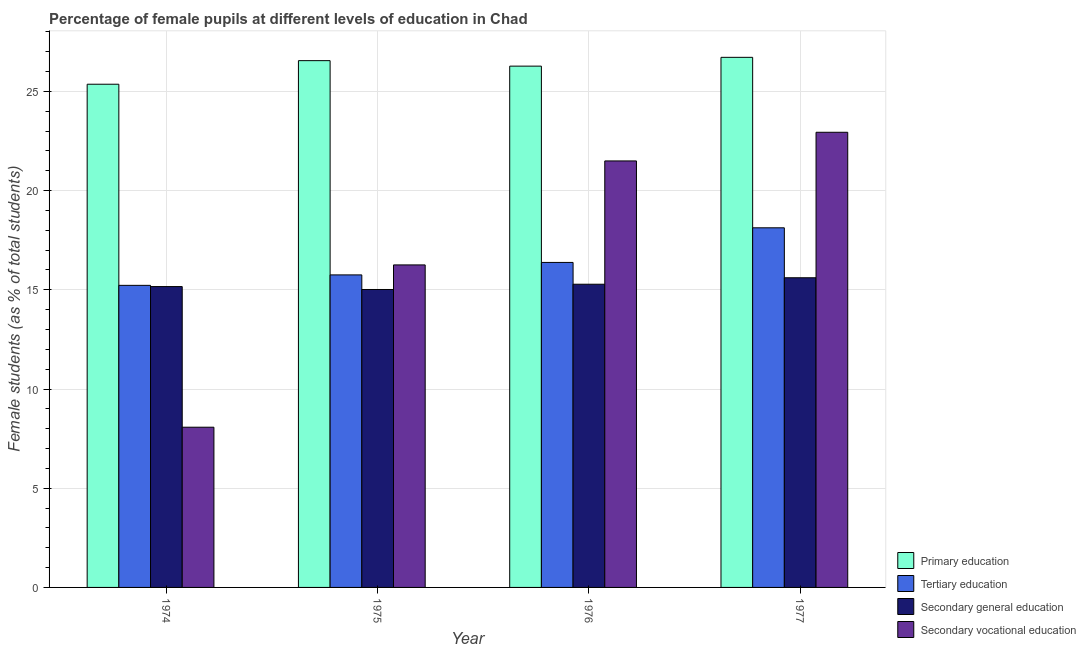How many different coloured bars are there?
Your answer should be very brief. 4. Are the number of bars on each tick of the X-axis equal?
Your response must be concise. Yes. How many bars are there on the 4th tick from the left?
Give a very brief answer. 4. What is the label of the 2nd group of bars from the left?
Provide a short and direct response. 1975. What is the percentage of female students in secondary education in 1975?
Make the answer very short. 15.02. Across all years, what is the maximum percentage of female students in secondary education?
Make the answer very short. 15.61. Across all years, what is the minimum percentage of female students in secondary vocational education?
Ensure brevity in your answer.  8.08. In which year was the percentage of female students in tertiary education maximum?
Keep it short and to the point. 1977. In which year was the percentage of female students in tertiary education minimum?
Offer a terse response. 1974. What is the total percentage of female students in tertiary education in the graph?
Provide a succinct answer. 65.49. What is the difference between the percentage of female students in primary education in 1974 and that in 1976?
Offer a very short reply. -0.91. What is the difference between the percentage of female students in tertiary education in 1977 and the percentage of female students in secondary vocational education in 1976?
Make the answer very short. 1.75. What is the average percentage of female students in tertiary education per year?
Your response must be concise. 16.37. In the year 1974, what is the difference between the percentage of female students in secondary vocational education and percentage of female students in tertiary education?
Give a very brief answer. 0. In how many years, is the percentage of female students in secondary education greater than 11 %?
Provide a succinct answer. 4. What is the ratio of the percentage of female students in secondary education in 1975 to that in 1977?
Provide a succinct answer. 0.96. What is the difference between the highest and the second highest percentage of female students in primary education?
Provide a succinct answer. 0.17. What is the difference between the highest and the lowest percentage of female students in tertiary education?
Your answer should be very brief. 2.9. In how many years, is the percentage of female students in tertiary education greater than the average percentage of female students in tertiary education taken over all years?
Your answer should be very brief. 2. What does the 4th bar from the left in 1976 represents?
Your answer should be very brief. Secondary vocational education. What does the 3rd bar from the right in 1977 represents?
Provide a succinct answer. Tertiary education. Are the values on the major ticks of Y-axis written in scientific E-notation?
Make the answer very short. No. Does the graph contain any zero values?
Your answer should be compact. No. Where does the legend appear in the graph?
Make the answer very short. Bottom right. What is the title of the graph?
Your response must be concise. Percentage of female pupils at different levels of education in Chad. What is the label or title of the Y-axis?
Your response must be concise. Female students (as % of total students). What is the Female students (as % of total students) of Primary education in 1974?
Provide a short and direct response. 25.36. What is the Female students (as % of total students) in Tertiary education in 1974?
Offer a very short reply. 15.23. What is the Female students (as % of total students) of Secondary general education in 1974?
Your answer should be compact. 15.17. What is the Female students (as % of total students) in Secondary vocational education in 1974?
Provide a succinct answer. 8.08. What is the Female students (as % of total students) of Primary education in 1975?
Your answer should be compact. 26.55. What is the Female students (as % of total students) of Tertiary education in 1975?
Your answer should be very brief. 15.75. What is the Female students (as % of total students) in Secondary general education in 1975?
Offer a very short reply. 15.02. What is the Female students (as % of total students) of Secondary vocational education in 1975?
Your answer should be very brief. 16.26. What is the Female students (as % of total students) of Primary education in 1976?
Your answer should be compact. 26.28. What is the Female students (as % of total students) of Tertiary education in 1976?
Your response must be concise. 16.38. What is the Female students (as % of total students) of Secondary general education in 1976?
Keep it short and to the point. 15.28. What is the Female students (as % of total students) in Secondary vocational education in 1976?
Ensure brevity in your answer.  21.5. What is the Female students (as % of total students) of Primary education in 1977?
Provide a short and direct response. 26.72. What is the Female students (as % of total students) of Tertiary education in 1977?
Your answer should be very brief. 18.13. What is the Female students (as % of total students) in Secondary general education in 1977?
Offer a very short reply. 15.61. What is the Female students (as % of total students) in Secondary vocational education in 1977?
Keep it short and to the point. 22.94. Across all years, what is the maximum Female students (as % of total students) of Primary education?
Your answer should be compact. 26.72. Across all years, what is the maximum Female students (as % of total students) of Tertiary education?
Your answer should be very brief. 18.13. Across all years, what is the maximum Female students (as % of total students) in Secondary general education?
Your response must be concise. 15.61. Across all years, what is the maximum Female students (as % of total students) in Secondary vocational education?
Provide a succinct answer. 22.94. Across all years, what is the minimum Female students (as % of total students) in Primary education?
Ensure brevity in your answer.  25.36. Across all years, what is the minimum Female students (as % of total students) in Tertiary education?
Give a very brief answer. 15.23. Across all years, what is the minimum Female students (as % of total students) of Secondary general education?
Give a very brief answer. 15.02. Across all years, what is the minimum Female students (as % of total students) in Secondary vocational education?
Make the answer very short. 8.08. What is the total Female students (as % of total students) in Primary education in the graph?
Keep it short and to the point. 104.91. What is the total Female students (as % of total students) in Tertiary education in the graph?
Provide a short and direct response. 65.49. What is the total Female students (as % of total students) in Secondary general education in the graph?
Provide a succinct answer. 61.07. What is the total Female students (as % of total students) of Secondary vocational education in the graph?
Keep it short and to the point. 68.77. What is the difference between the Female students (as % of total students) of Primary education in 1974 and that in 1975?
Your answer should be compact. -1.19. What is the difference between the Female students (as % of total students) of Tertiary education in 1974 and that in 1975?
Your response must be concise. -0.53. What is the difference between the Female students (as % of total students) in Secondary general education in 1974 and that in 1975?
Provide a short and direct response. 0.15. What is the difference between the Female students (as % of total students) in Secondary vocational education in 1974 and that in 1975?
Provide a short and direct response. -8.18. What is the difference between the Female students (as % of total students) of Primary education in 1974 and that in 1976?
Give a very brief answer. -0.91. What is the difference between the Female students (as % of total students) in Tertiary education in 1974 and that in 1976?
Provide a short and direct response. -1.16. What is the difference between the Female students (as % of total students) of Secondary general education in 1974 and that in 1976?
Make the answer very short. -0.12. What is the difference between the Female students (as % of total students) of Secondary vocational education in 1974 and that in 1976?
Provide a succinct answer. -13.42. What is the difference between the Female students (as % of total students) of Primary education in 1974 and that in 1977?
Offer a very short reply. -1.36. What is the difference between the Female students (as % of total students) of Tertiary education in 1974 and that in 1977?
Give a very brief answer. -2.9. What is the difference between the Female students (as % of total students) in Secondary general education in 1974 and that in 1977?
Give a very brief answer. -0.44. What is the difference between the Female students (as % of total students) of Secondary vocational education in 1974 and that in 1977?
Your response must be concise. -14.87. What is the difference between the Female students (as % of total students) in Primary education in 1975 and that in 1976?
Offer a very short reply. 0.28. What is the difference between the Female students (as % of total students) in Tertiary education in 1975 and that in 1976?
Offer a very short reply. -0.63. What is the difference between the Female students (as % of total students) in Secondary general education in 1975 and that in 1976?
Ensure brevity in your answer.  -0.27. What is the difference between the Female students (as % of total students) of Secondary vocational education in 1975 and that in 1976?
Give a very brief answer. -5.24. What is the difference between the Female students (as % of total students) of Primary education in 1975 and that in 1977?
Ensure brevity in your answer.  -0.17. What is the difference between the Female students (as % of total students) of Tertiary education in 1975 and that in 1977?
Ensure brevity in your answer.  -2.37. What is the difference between the Female students (as % of total students) of Secondary general education in 1975 and that in 1977?
Offer a terse response. -0.59. What is the difference between the Female students (as % of total students) of Secondary vocational education in 1975 and that in 1977?
Provide a short and direct response. -6.69. What is the difference between the Female students (as % of total students) in Primary education in 1976 and that in 1977?
Ensure brevity in your answer.  -0.44. What is the difference between the Female students (as % of total students) of Tertiary education in 1976 and that in 1977?
Offer a very short reply. -1.75. What is the difference between the Female students (as % of total students) in Secondary general education in 1976 and that in 1977?
Give a very brief answer. -0.33. What is the difference between the Female students (as % of total students) of Secondary vocational education in 1976 and that in 1977?
Ensure brevity in your answer.  -1.44. What is the difference between the Female students (as % of total students) of Primary education in 1974 and the Female students (as % of total students) of Tertiary education in 1975?
Provide a succinct answer. 9.61. What is the difference between the Female students (as % of total students) in Primary education in 1974 and the Female students (as % of total students) in Secondary general education in 1975?
Give a very brief answer. 10.35. What is the difference between the Female students (as % of total students) in Primary education in 1974 and the Female students (as % of total students) in Secondary vocational education in 1975?
Ensure brevity in your answer.  9.11. What is the difference between the Female students (as % of total students) in Tertiary education in 1974 and the Female students (as % of total students) in Secondary general education in 1975?
Your response must be concise. 0.21. What is the difference between the Female students (as % of total students) in Tertiary education in 1974 and the Female students (as % of total students) in Secondary vocational education in 1975?
Your response must be concise. -1.03. What is the difference between the Female students (as % of total students) of Secondary general education in 1974 and the Female students (as % of total students) of Secondary vocational education in 1975?
Your response must be concise. -1.09. What is the difference between the Female students (as % of total students) in Primary education in 1974 and the Female students (as % of total students) in Tertiary education in 1976?
Give a very brief answer. 8.98. What is the difference between the Female students (as % of total students) in Primary education in 1974 and the Female students (as % of total students) in Secondary general education in 1976?
Provide a succinct answer. 10.08. What is the difference between the Female students (as % of total students) in Primary education in 1974 and the Female students (as % of total students) in Secondary vocational education in 1976?
Provide a short and direct response. 3.87. What is the difference between the Female students (as % of total students) of Tertiary education in 1974 and the Female students (as % of total students) of Secondary general education in 1976?
Your response must be concise. -0.06. What is the difference between the Female students (as % of total students) of Tertiary education in 1974 and the Female students (as % of total students) of Secondary vocational education in 1976?
Provide a succinct answer. -6.27. What is the difference between the Female students (as % of total students) of Secondary general education in 1974 and the Female students (as % of total students) of Secondary vocational education in 1976?
Make the answer very short. -6.33. What is the difference between the Female students (as % of total students) of Primary education in 1974 and the Female students (as % of total students) of Tertiary education in 1977?
Ensure brevity in your answer.  7.24. What is the difference between the Female students (as % of total students) of Primary education in 1974 and the Female students (as % of total students) of Secondary general education in 1977?
Keep it short and to the point. 9.75. What is the difference between the Female students (as % of total students) of Primary education in 1974 and the Female students (as % of total students) of Secondary vocational education in 1977?
Your answer should be very brief. 2.42. What is the difference between the Female students (as % of total students) in Tertiary education in 1974 and the Female students (as % of total students) in Secondary general education in 1977?
Offer a very short reply. -0.38. What is the difference between the Female students (as % of total students) of Tertiary education in 1974 and the Female students (as % of total students) of Secondary vocational education in 1977?
Make the answer very short. -7.72. What is the difference between the Female students (as % of total students) of Secondary general education in 1974 and the Female students (as % of total students) of Secondary vocational education in 1977?
Make the answer very short. -7.78. What is the difference between the Female students (as % of total students) in Primary education in 1975 and the Female students (as % of total students) in Tertiary education in 1976?
Make the answer very short. 10.17. What is the difference between the Female students (as % of total students) of Primary education in 1975 and the Female students (as % of total students) of Secondary general education in 1976?
Make the answer very short. 11.27. What is the difference between the Female students (as % of total students) of Primary education in 1975 and the Female students (as % of total students) of Secondary vocational education in 1976?
Give a very brief answer. 5.05. What is the difference between the Female students (as % of total students) in Tertiary education in 1975 and the Female students (as % of total students) in Secondary general education in 1976?
Make the answer very short. 0.47. What is the difference between the Female students (as % of total students) in Tertiary education in 1975 and the Female students (as % of total students) in Secondary vocational education in 1976?
Ensure brevity in your answer.  -5.74. What is the difference between the Female students (as % of total students) in Secondary general education in 1975 and the Female students (as % of total students) in Secondary vocational education in 1976?
Your answer should be very brief. -6.48. What is the difference between the Female students (as % of total students) in Primary education in 1975 and the Female students (as % of total students) in Tertiary education in 1977?
Your answer should be compact. 8.43. What is the difference between the Female students (as % of total students) in Primary education in 1975 and the Female students (as % of total students) in Secondary general education in 1977?
Keep it short and to the point. 10.94. What is the difference between the Female students (as % of total students) of Primary education in 1975 and the Female students (as % of total students) of Secondary vocational education in 1977?
Offer a terse response. 3.61. What is the difference between the Female students (as % of total students) in Tertiary education in 1975 and the Female students (as % of total students) in Secondary general education in 1977?
Give a very brief answer. 0.14. What is the difference between the Female students (as % of total students) of Tertiary education in 1975 and the Female students (as % of total students) of Secondary vocational education in 1977?
Provide a short and direct response. -7.19. What is the difference between the Female students (as % of total students) of Secondary general education in 1975 and the Female students (as % of total students) of Secondary vocational education in 1977?
Offer a very short reply. -7.93. What is the difference between the Female students (as % of total students) in Primary education in 1976 and the Female students (as % of total students) in Tertiary education in 1977?
Make the answer very short. 8.15. What is the difference between the Female students (as % of total students) in Primary education in 1976 and the Female students (as % of total students) in Secondary general education in 1977?
Your answer should be very brief. 10.67. What is the difference between the Female students (as % of total students) in Primary education in 1976 and the Female students (as % of total students) in Secondary vocational education in 1977?
Keep it short and to the point. 3.33. What is the difference between the Female students (as % of total students) in Tertiary education in 1976 and the Female students (as % of total students) in Secondary general education in 1977?
Ensure brevity in your answer.  0.77. What is the difference between the Female students (as % of total students) in Tertiary education in 1976 and the Female students (as % of total students) in Secondary vocational education in 1977?
Give a very brief answer. -6.56. What is the difference between the Female students (as % of total students) of Secondary general education in 1976 and the Female students (as % of total students) of Secondary vocational education in 1977?
Provide a succinct answer. -7.66. What is the average Female students (as % of total students) of Primary education per year?
Keep it short and to the point. 26.23. What is the average Female students (as % of total students) in Tertiary education per year?
Your answer should be compact. 16.37. What is the average Female students (as % of total students) of Secondary general education per year?
Provide a succinct answer. 15.27. What is the average Female students (as % of total students) in Secondary vocational education per year?
Your answer should be very brief. 17.19. In the year 1974, what is the difference between the Female students (as % of total students) of Primary education and Female students (as % of total students) of Tertiary education?
Make the answer very short. 10.14. In the year 1974, what is the difference between the Female students (as % of total students) in Primary education and Female students (as % of total students) in Secondary general education?
Provide a succinct answer. 10.2. In the year 1974, what is the difference between the Female students (as % of total students) of Primary education and Female students (as % of total students) of Secondary vocational education?
Make the answer very short. 17.29. In the year 1974, what is the difference between the Female students (as % of total students) of Tertiary education and Female students (as % of total students) of Secondary general education?
Make the answer very short. 0.06. In the year 1974, what is the difference between the Female students (as % of total students) in Tertiary education and Female students (as % of total students) in Secondary vocational education?
Give a very brief answer. 7.15. In the year 1974, what is the difference between the Female students (as % of total students) of Secondary general education and Female students (as % of total students) of Secondary vocational education?
Your answer should be very brief. 7.09. In the year 1975, what is the difference between the Female students (as % of total students) of Primary education and Female students (as % of total students) of Tertiary education?
Keep it short and to the point. 10.8. In the year 1975, what is the difference between the Female students (as % of total students) in Primary education and Female students (as % of total students) in Secondary general education?
Offer a terse response. 11.54. In the year 1975, what is the difference between the Female students (as % of total students) of Primary education and Female students (as % of total students) of Secondary vocational education?
Provide a succinct answer. 10.3. In the year 1975, what is the difference between the Female students (as % of total students) of Tertiary education and Female students (as % of total students) of Secondary general education?
Your answer should be very brief. 0.74. In the year 1975, what is the difference between the Female students (as % of total students) of Tertiary education and Female students (as % of total students) of Secondary vocational education?
Make the answer very short. -0.5. In the year 1975, what is the difference between the Female students (as % of total students) of Secondary general education and Female students (as % of total students) of Secondary vocational education?
Keep it short and to the point. -1.24. In the year 1976, what is the difference between the Female students (as % of total students) of Primary education and Female students (as % of total students) of Tertiary education?
Make the answer very short. 9.89. In the year 1976, what is the difference between the Female students (as % of total students) in Primary education and Female students (as % of total students) in Secondary general education?
Offer a terse response. 10.99. In the year 1976, what is the difference between the Female students (as % of total students) in Primary education and Female students (as % of total students) in Secondary vocational education?
Offer a terse response. 4.78. In the year 1976, what is the difference between the Female students (as % of total students) of Tertiary education and Female students (as % of total students) of Secondary general education?
Provide a short and direct response. 1.1. In the year 1976, what is the difference between the Female students (as % of total students) of Tertiary education and Female students (as % of total students) of Secondary vocational education?
Your answer should be very brief. -5.12. In the year 1976, what is the difference between the Female students (as % of total students) in Secondary general education and Female students (as % of total students) in Secondary vocational education?
Keep it short and to the point. -6.22. In the year 1977, what is the difference between the Female students (as % of total students) of Primary education and Female students (as % of total students) of Tertiary education?
Offer a terse response. 8.59. In the year 1977, what is the difference between the Female students (as % of total students) in Primary education and Female students (as % of total students) in Secondary general education?
Keep it short and to the point. 11.11. In the year 1977, what is the difference between the Female students (as % of total students) of Primary education and Female students (as % of total students) of Secondary vocational education?
Keep it short and to the point. 3.78. In the year 1977, what is the difference between the Female students (as % of total students) in Tertiary education and Female students (as % of total students) in Secondary general education?
Ensure brevity in your answer.  2.52. In the year 1977, what is the difference between the Female students (as % of total students) in Tertiary education and Female students (as % of total students) in Secondary vocational education?
Provide a succinct answer. -4.82. In the year 1977, what is the difference between the Female students (as % of total students) of Secondary general education and Female students (as % of total students) of Secondary vocational education?
Make the answer very short. -7.33. What is the ratio of the Female students (as % of total students) of Primary education in 1974 to that in 1975?
Offer a terse response. 0.96. What is the ratio of the Female students (as % of total students) of Tertiary education in 1974 to that in 1975?
Your response must be concise. 0.97. What is the ratio of the Female students (as % of total students) in Secondary general education in 1974 to that in 1975?
Ensure brevity in your answer.  1.01. What is the ratio of the Female students (as % of total students) in Secondary vocational education in 1974 to that in 1975?
Provide a short and direct response. 0.5. What is the ratio of the Female students (as % of total students) in Primary education in 1974 to that in 1976?
Your answer should be very brief. 0.97. What is the ratio of the Female students (as % of total students) of Tertiary education in 1974 to that in 1976?
Give a very brief answer. 0.93. What is the ratio of the Female students (as % of total students) of Secondary general education in 1974 to that in 1976?
Give a very brief answer. 0.99. What is the ratio of the Female students (as % of total students) in Secondary vocational education in 1974 to that in 1976?
Offer a terse response. 0.38. What is the ratio of the Female students (as % of total students) in Primary education in 1974 to that in 1977?
Your answer should be compact. 0.95. What is the ratio of the Female students (as % of total students) in Tertiary education in 1974 to that in 1977?
Offer a very short reply. 0.84. What is the ratio of the Female students (as % of total students) in Secondary general education in 1974 to that in 1977?
Your answer should be very brief. 0.97. What is the ratio of the Female students (as % of total students) of Secondary vocational education in 1974 to that in 1977?
Provide a succinct answer. 0.35. What is the ratio of the Female students (as % of total students) of Primary education in 1975 to that in 1976?
Provide a succinct answer. 1.01. What is the ratio of the Female students (as % of total students) of Tertiary education in 1975 to that in 1976?
Offer a very short reply. 0.96. What is the ratio of the Female students (as % of total students) of Secondary general education in 1975 to that in 1976?
Provide a short and direct response. 0.98. What is the ratio of the Female students (as % of total students) of Secondary vocational education in 1975 to that in 1976?
Provide a short and direct response. 0.76. What is the ratio of the Female students (as % of total students) in Tertiary education in 1975 to that in 1977?
Offer a terse response. 0.87. What is the ratio of the Female students (as % of total students) in Secondary general education in 1975 to that in 1977?
Provide a succinct answer. 0.96. What is the ratio of the Female students (as % of total students) in Secondary vocational education in 1975 to that in 1977?
Provide a succinct answer. 0.71. What is the ratio of the Female students (as % of total students) in Primary education in 1976 to that in 1977?
Keep it short and to the point. 0.98. What is the ratio of the Female students (as % of total students) of Tertiary education in 1976 to that in 1977?
Ensure brevity in your answer.  0.9. What is the ratio of the Female students (as % of total students) of Secondary general education in 1976 to that in 1977?
Give a very brief answer. 0.98. What is the ratio of the Female students (as % of total students) in Secondary vocational education in 1976 to that in 1977?
Keep it short and to the point. 0.94. What is the difference between the highest and the second highest Female students (as % of total students) in Primary education?
Provide a short and direct response. 0.17. What is the difference between the highest and the second highest Female students (as % of total students) in Tertiary education?
Provide a short and direct response. 1.75. What is the difference between the highest and the second highest Female students (as % of total students) in Secondary general education?
Make the answer very short. 0.33. What is the difference between the highest and the second highest Female students (as % of total students) of Secondary vocational education?
Your answer should be compact. 1.44. What is the difference between the highest and the lowest Female students (as % of total students) in Primary education?
Offer a terse response. 1.36. What is the difference between the highest and the lowest Female students (as % of total students) in Tertiary education?
Your answer should be compact. 2.9. What is the difference between the highest and the lowest Female students (as % of total students) in Secondary general education?
Offer a very short reply. 0.59. What is the difference between the highest and the lowest Female students (as % of total students) of Secondary vocational education?
Provide a succinct answer. 14.87. 